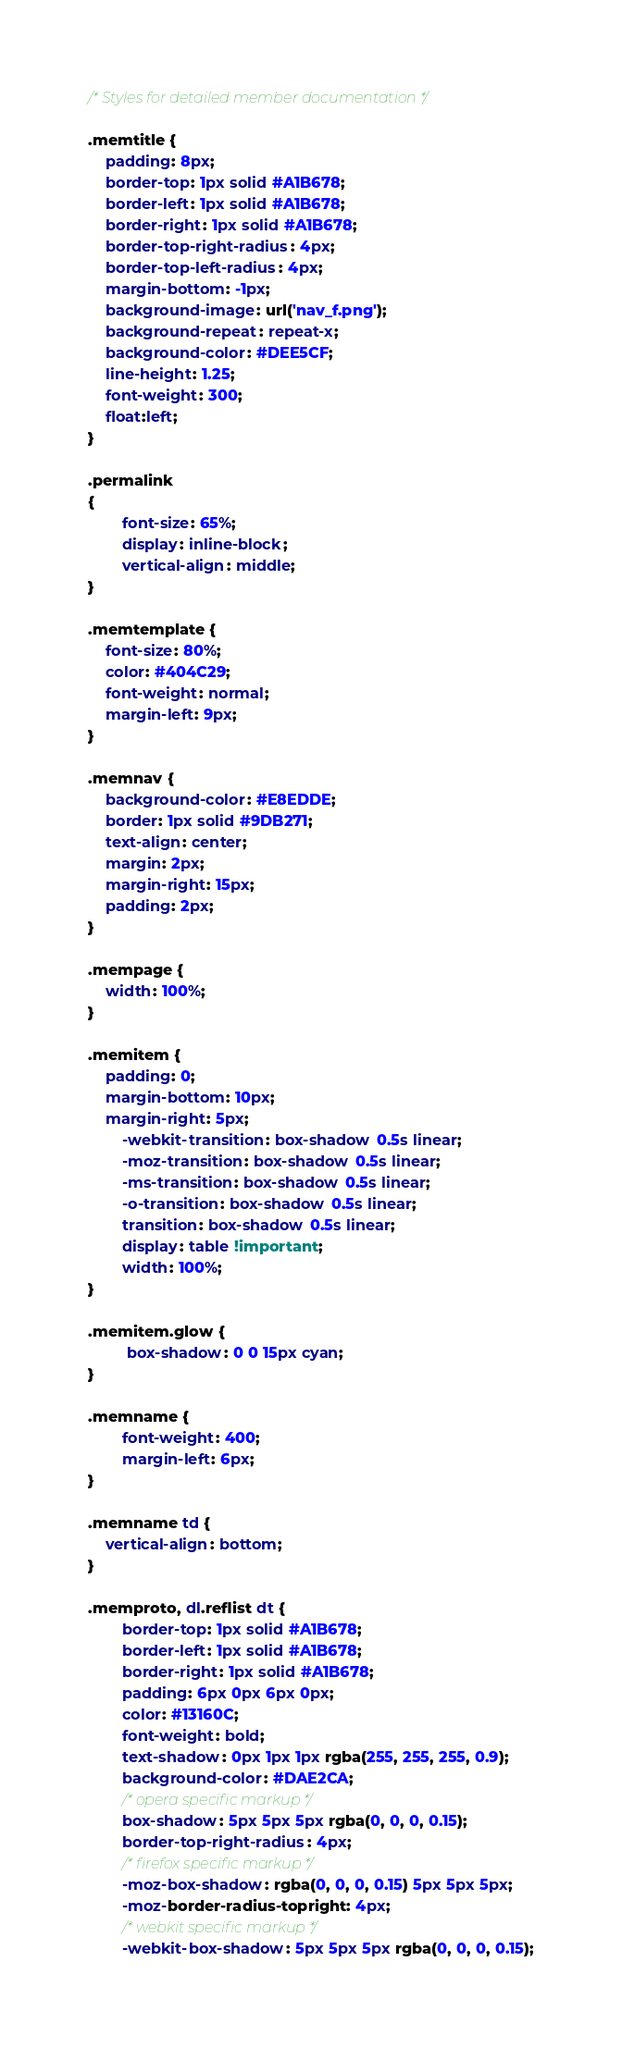<code> <loc_0><loc_0><loc_500><loc_500><_CSS_>
/* Styles for detailed member documentation */

.memtitle {
	padding: 8px;
	border-top: 1px solid #A1B678;
	border-left: 1px solid #A1B678;
	border-right: 1px solid #A1B678;
	border-top-right-radius: 4px;
	border-top-left-radius: 4px;
	margin-bottom: -1px;
	background-image: url('nav_f.png');
	background-repeat: repeat-x;
	background-color: #DEE5CF;
	line-height: 1.25;
	font-weight: 300;
	float:left;
}

.permalink
{
        font-size: 65%;
        display: inline-block;
        vertical-align: middle;
}

.memtemplate {
	font-size: 80%;
	color: #404C29;
	font-weight: normal;
	margin-left: 9px;
}

.memnav {
	background-color: #E8EDDE;
	border: 1px solid #9DB271;
	text-align: center;
	margin: 2px;
	margin-right: 15px;
	padding: 2px;
}

.mempage {
	width: 100%;
}

.memitem {
	padding: 0;
	margin-bottom: 10px;
	margin-right: 5px;
        -webkit-transition: box-shadow 0.5s linear;
        -moz-transition: box-shadow 0.5s linear;
        -ms-transition: box-shadow 0.5s linear;
        -o-transition: box-shadow 0.5s linear;
        transition: box-shadow 0.5s linear;
        display: table !important;
        width: 100%;
}

.memitem.glow {
         box-shadow: 0 0 15px cyan;
}

.memname {
        font-weight: 400;
        margin-left: 6px;
}

.memname td {
	vertical-align: bottom;
}

.memproto, dl.reflist dt {
        border-top: 1px solid #A1B678;
        border-left: 1px solid #A1B678;
        border-right: 1px solid #A1B678;
        padding: 6px 0px 6px 0px;
        color: #13160C;
        font-weight: bold;
        text-shadow: 0px 1px 1px rgba(255, 255, 255, 0.9);
        background-color: #DAE2CA;
        /* opera specific markup */
        box-shadow: 5px 5px 5px rgba(0, 0, 0, 0.15);
        border-top-right-radius: 4px;
        /* firefox specific markup */
        -moz-box-shadow: rgba(0, 0, 0, 0.15) 5px 5px 5px;
        -moz-border-radius-topright: 4px;
        /* webkit specific markup */
        -webkit-box-shadow: 5px 5px 5px rgba(0, 0, 0, 0.15);</code> 